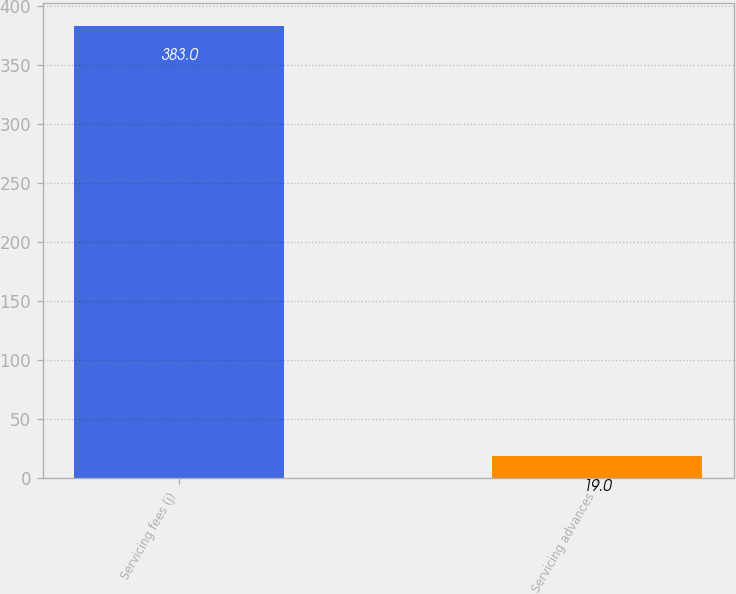Convert chart to OTSL. <chart><loc_0><loc_0><loc_500><loc_500><bar_chart><fcel>Servicing fees (j)<fcel>Servicing advances<nl><fcel>383<fcel>19<nl></chart> 